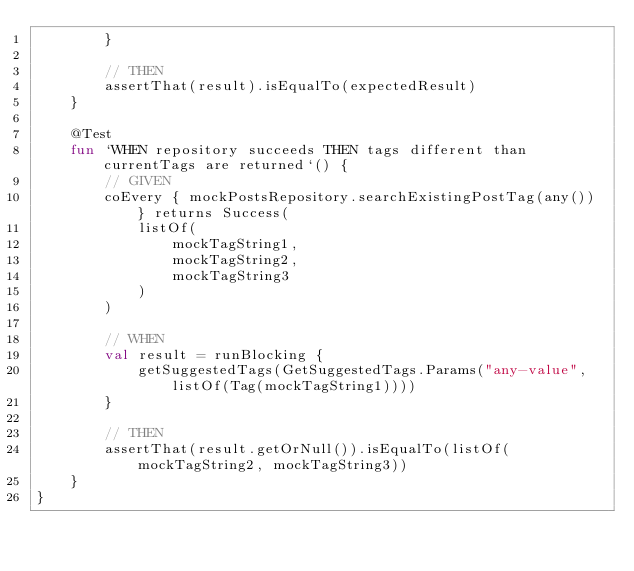<code> <loc_0><loc_0><loc_500><loc_500><_Kotlin_>        }

        // THEN
        assertThat(result).isEqualTo(expectedResult)
    }

    @Test
    fun `WHEN repository succeeds THEN tags different than currentTags are returned`() {
        // GIVEN
        coEvery { mockPostsRepository.searchExistingPostTag(any()) } returns Success(
            listOf(
                mockTagString1,
                mockTagString2,
                mockTagString3
            )
        )

        // WHEN
        val result = runBlocking {
            getSuggestedTags(GetSuggestedTags.Params("any-value", listOf(Tag(mockTagString1))))
        }

        // THEN
        assertThat(result.getOrNull()).isEqualTo(listOf(mockTagString2, mockTagString3))
    }
}
</code> 